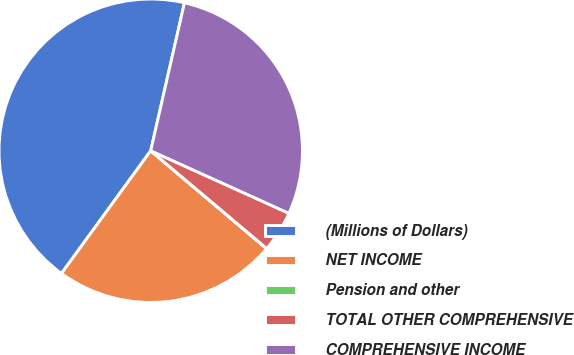Convert chart. <chart><loc_0><loc_0><loc_500><loc_500><pie_chart><fcel>(Millions of Dollars)<fcel>NET INCOME<fcel>Pension and other<fcel>TOTAL OTHER COMPREHENSIVE<fcel>COMPREHENSIVE INCOME<nl><fcel>43.56%<fcel>23.84%<fcel>0.02%<fcel>4.38%<fcel>28.2%<nl></chart> 